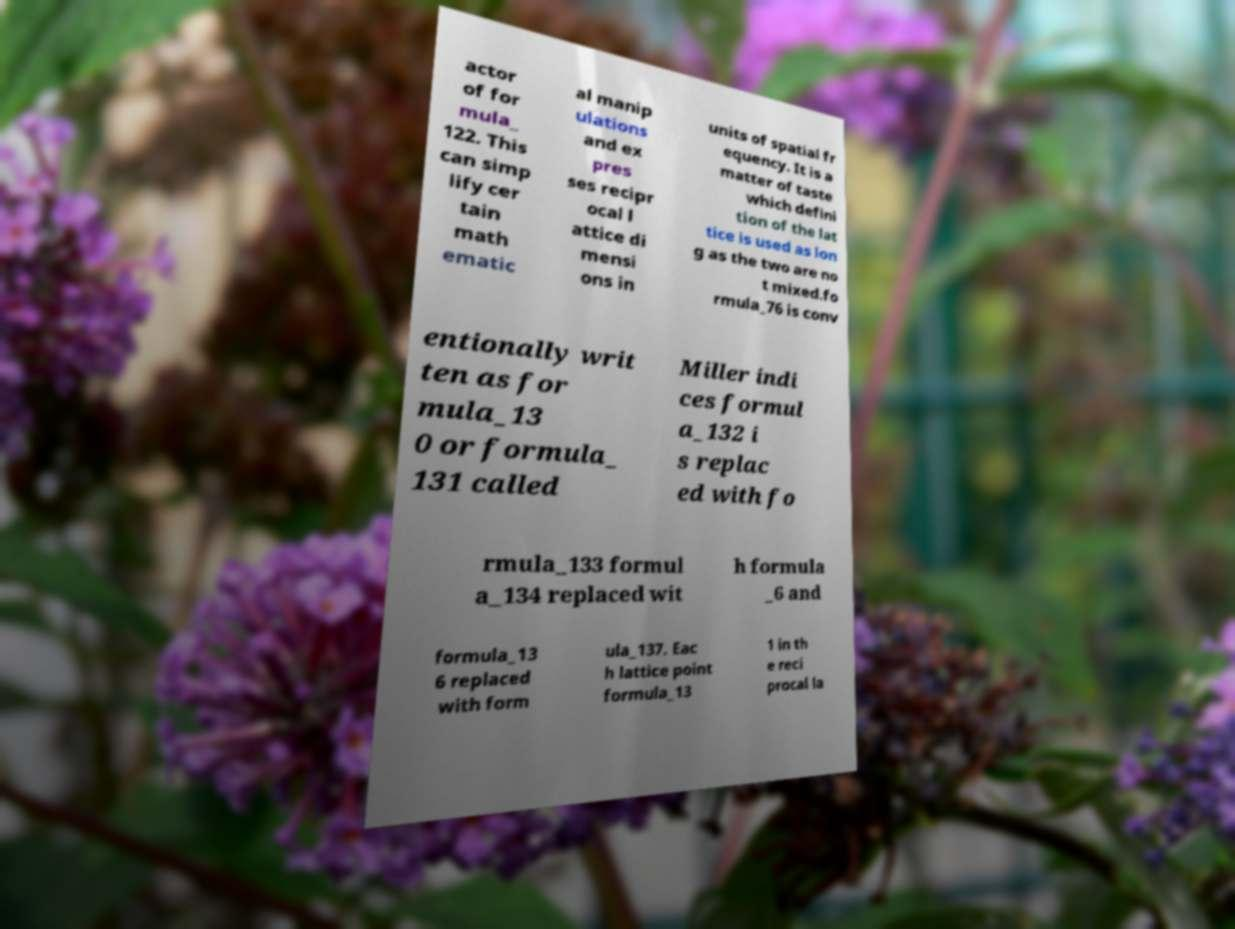Could you extract and type out the text from this image? actor of for mula_ 122. This can simp lify cer tain math ematic al manip ulations and ex pres ses recipr ocal l attice di mensi ons in units of spatial fr equency. It is a matter of taste which defini tion of the lat tice is used as lon g as the two are no t mixed.fo rmula_76 is conv entionally writ ten as for mula_13 0 or formula_ 131 called Miller indi ces formul a_132 i s replac ed with fo rmula_133 formul a_134 replaced wit h formula _6 and formula_13 6 replaced with form ula_137. Eac h lattice point formula_13 1 in th e reci procal la 